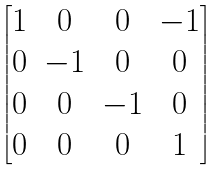<formula> <loc_0><loc_0><loc_500><loc_500>\begin{bmatrix} 1 & 0 & 0 & - 1 \\ 0 & - 1 & 0 & 0 \\ 0 & 0 & - 1 & 0 \\ 0 & 0 & 0 & 1 \end{bmatrix}</formula> 